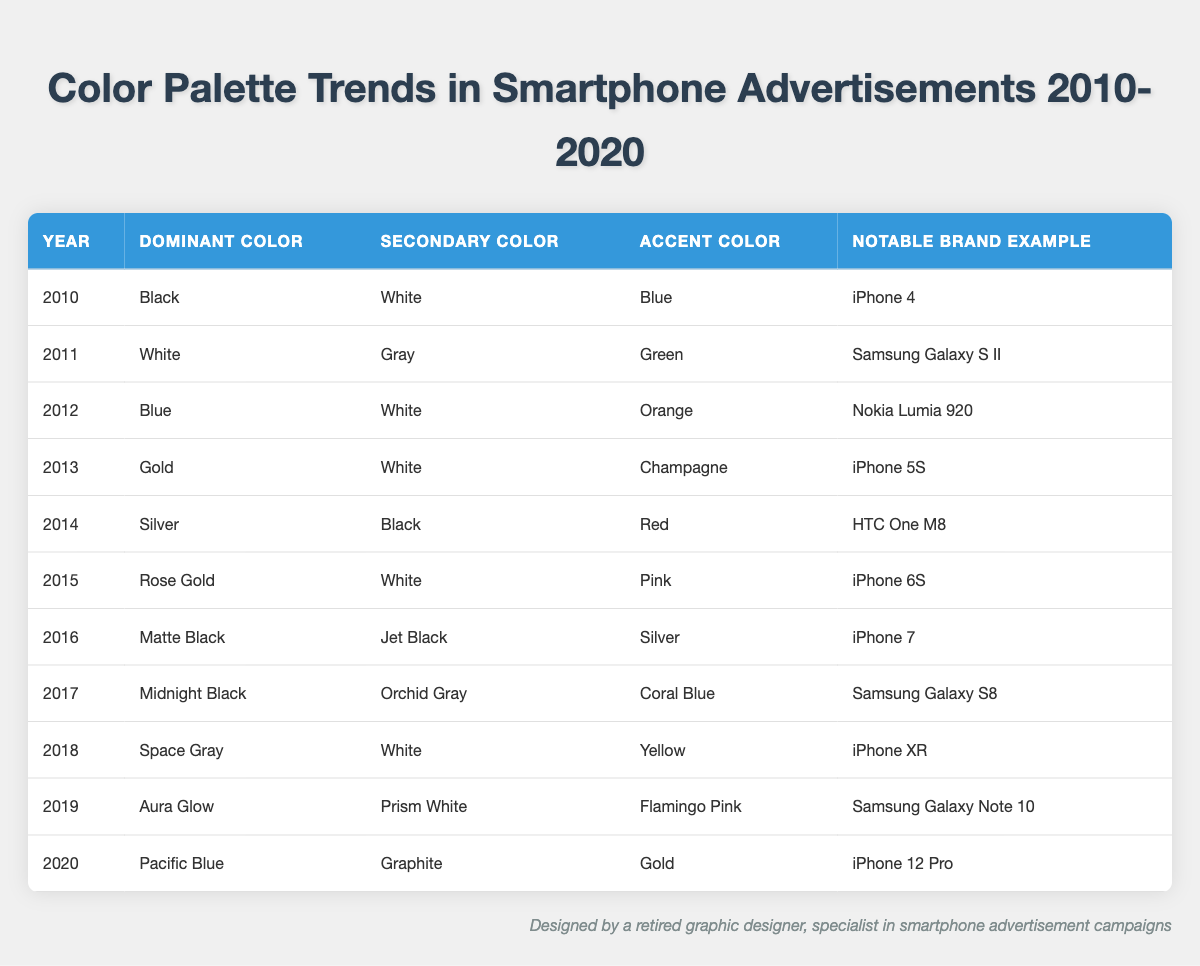What was the dominant color in 2015? The table shows the color palette trends for each year. In 2015, the dominant color is listed as Rose Gold.
Answer: Rose Gold Which year featured the color Pacific Blue? By scanning the table, Pacific Blue appears as the dominant color for the year 2020.
Answer: 2020 Was Gold a dominant color in any year? Looking through the table, Gold is identified as the dominant color for the year 2013.
Answer: Yes In which years did White serve as the secondary color? The table indicates that White served as the secondary color for the years 2010, 2011, 2012, 2013, 2015, and 2018. Counting these instances gives us a total of six years.
Answer: 6 years What is the average number of colors used in the advertisements per year? Each row of the table includes three colors: dominant, secondary, and accent. This sums up to three colors per year across 11 years. Therefore, the average is simply 3 since it's constant for each year.
Answer: 3 How many advertisements featured black as a dominant or secondary color? The table reveals that Black was the dominant color in 2010, 2014, and 2016. Additionally, Black was the secondary color in 2014 and 2017. Altogether, Black appeared five times across these five years in significant color roles.
Answer: 5 times Which color combination was most common in the smartphones from 2010-2020? Analyzing the table for recurring combinations, the combination of Black and White appears notably in 2010 as dominant and secondary respectively and then again with Black as a secondary color in 2014. Although the most common may not be quantitatively derived since each year varies, this specific duo is prominently featured.
Answer: Black and White In which year did the iPhone 12 Pro release, and what were its colors? The table states that the iPhone 12 Pro was released in 2020, featuring Pacific Blue as the dominant color, Graphite as the secondary color, and Gold as the accent color.
Answer: 2020, Pacific Blue, Graphite, Gold 